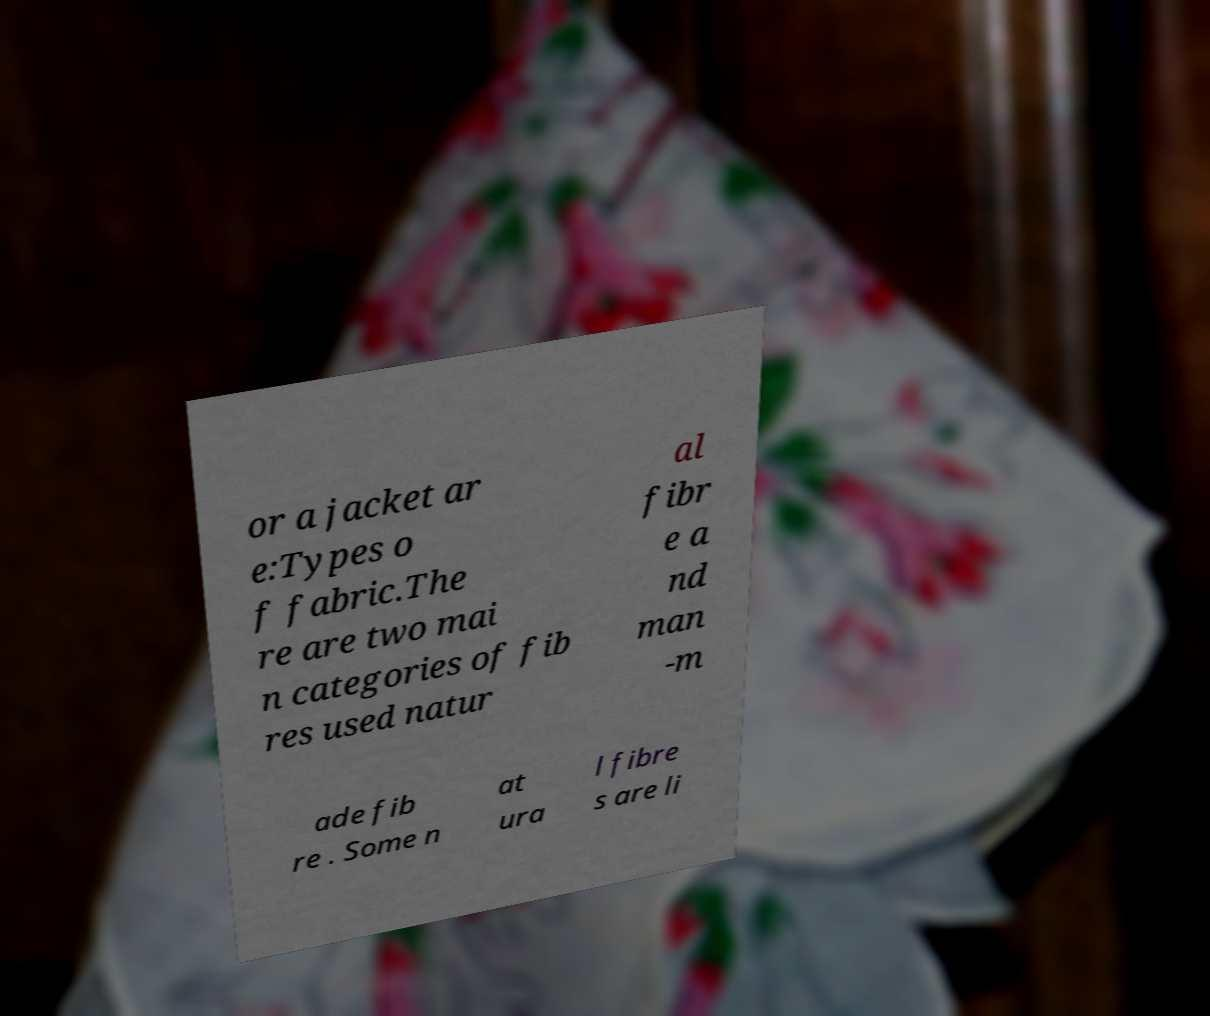I need the written content from this picture converted into text. Can you do that? or a jacket ar e:Types o f fabric.The re are two mai n categories of fib res used natur al fibr e a nd man -m ade fib re . Some n at ura l fibre s are li 